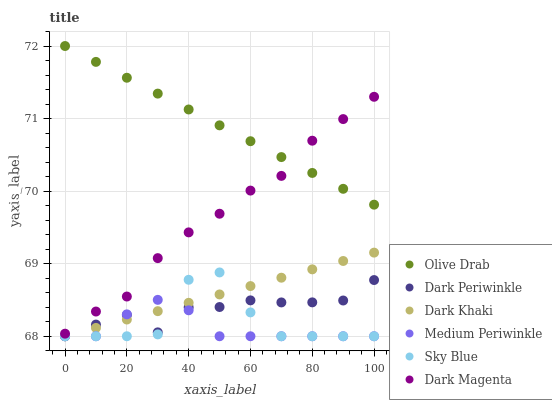Does Medium Periwinkle have the minimum area under the curve?
Answer yes or no. Yes. Does Olive Drab have the maximum area under the curve?
Answer yes or no. Yes. Does Dark Khaki have the minimum area under the curve?
Answer yes or no. No. Does Dark Khaki have the maximum area under the curve?
Answer yes or no. No. Is Olive Drab the smoothest?
Answer yes or no. Yes. Is Sky Blue the roughest?
Answer yes or no. Yes. Is Medium Periwinkle the smoothest?
Answer yes or no. No. Is Medium Periwinkle the roughest?
Answer yes or no. No. Does Medium Periwinkle have the lowest value?
Answer yes or no. Yes. Does Olive Drab have the lowest value?
Answer yes or no. No. Does Olive Drab have the highest value?
Answer yes or no. Yes. Does Dark Khaki have the highest value?
Answer yes or no. No. Is Dark Periwinkle less than Olive Drab?
Answer yes or no. Yes. Is Olive Drab greater than Medium Periwinkle?
Answer yes or no. Yes. Does Sky Blue intersect Medium Periwinkle?
Answer yes or no. Yes. Is Sky Blue less than Medium Periwinkle?
Answer yes or no. No. Is Sky Blue greater than Medium Periwinkle?
Answer yes or no. No. Does Dark Periwinkle intersect Olive Drab?
Answer yes or no. No. 